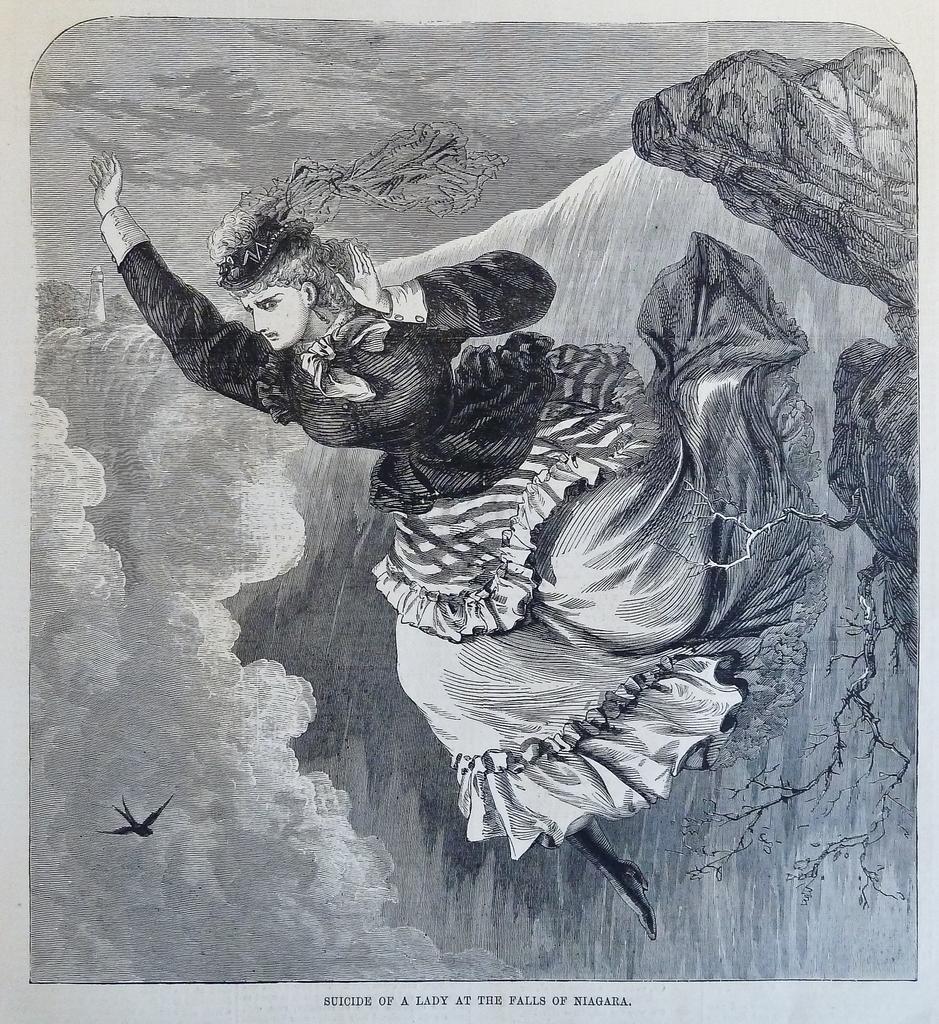How would you summarize this image in a sentence or two? In this picture we can see an art and some text. 